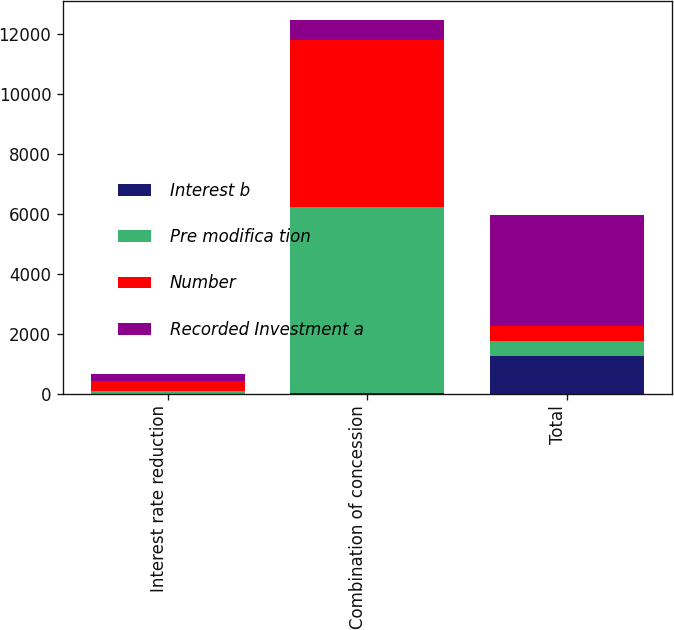<chart> <loc_0><loc_0><loc_500><loc_500><stacked_bar_chart><ecel><fcel>Interest rate reduction<fcel>Combination of concession<fcel>Total<nl><fcel>Interest b<fcel>1<fcel>11<fcel>1258<nl><fcel>Pre modifica tion<fcel>104<fcel>6229<fcel>493<nl><fcel>Number<fcel>335<fcel>5578<fcel>493<nl><fcel>Recorded Investment a<fcel>231<fcel>651<fcel>3723<nl></chart> 